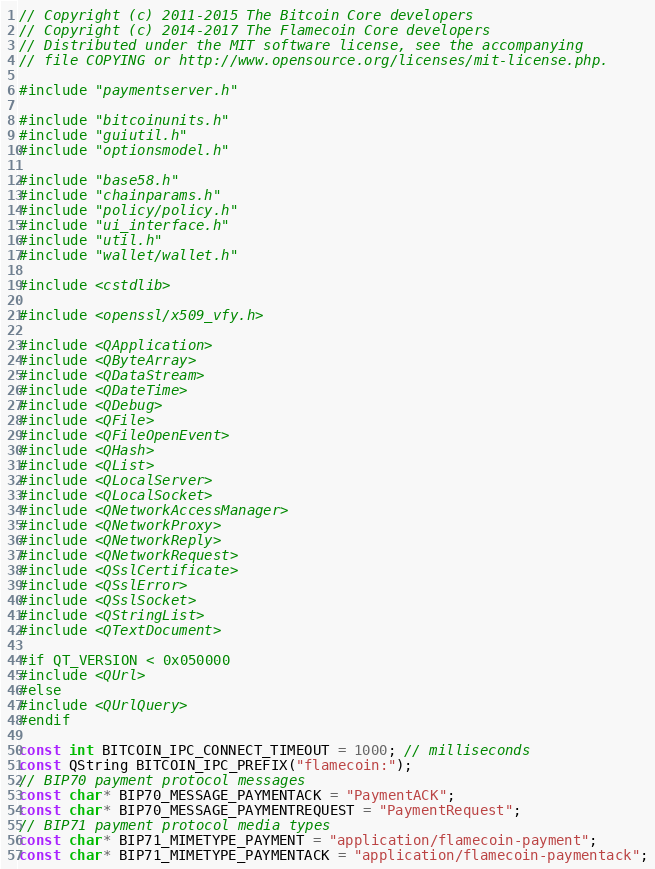<code> <loc_0><loc_0><loc_500><loc_500><_C++_>// Copyright (c) 2011-2015 The Bitcoin Core developers
// Copyright (c) 2014-2017 The Flamecoin Core developers
// Distributed under the MIT software license, see the accompanying
// file COPYING or http://www.opensource.org/licenses/mit-license.php.

#include "paymentserver.h"

#include "bitcoinunits.h"
#include "guiutil.h"
#include "optionsmodel.h"

#include "base58.h"
#include "chainparams.h"
#include "policy/policy.h"
#include "ui_interface.h"
#include "util.h"
#include "wallet/wallet.h"

#include <cstdlib>

#include <openssl/x509_vfy.h>

#include <QApplication>
#include <QByteArray>
#include <QDataStream>
#include <QDateTime>
#include <QDebug>
#include <QFile>
#include <QFileOpenEvent>
#include <QHash>
#include <QList>
#include <QLocalServer>
#include <QLocalSocket>
#include <QNetworkAccessManager>
#include <QNetworkProxy>
#include <QNetworkReply>
#include <QNetworkRequest>
#include <QSslCertificate>
#include <QSslError>
#include <QSslSocket>
#include <QStringList>
#include <QTextDocument>

#if QT_VERSION < 0x050000
#include <QUrl>
#else
#include <QUrlQuery>
#endif

const int BITCOIN_IPC_CONNECT_TIMEOUT = 1000; // milliseconds
const QString BITCOIN_IPC_PREFIX("flamecoin:");
// BIP70 payment protocol messages
const char* BIP70_MESSAGE_PAYMENTACK = "PaymentACK";
const char* BIP70_MESSAGE_PAYMENTREQUEST = "PaymentRequest";
// BIP71 payment protocol media types
const char* BIP71_MIMETYPE_PAYMENT = "application/flamecoin-payment";
const char* BIP71_MIMETYPE_PAYMENTACK = "application/flamecoin-paymentack";</code> 